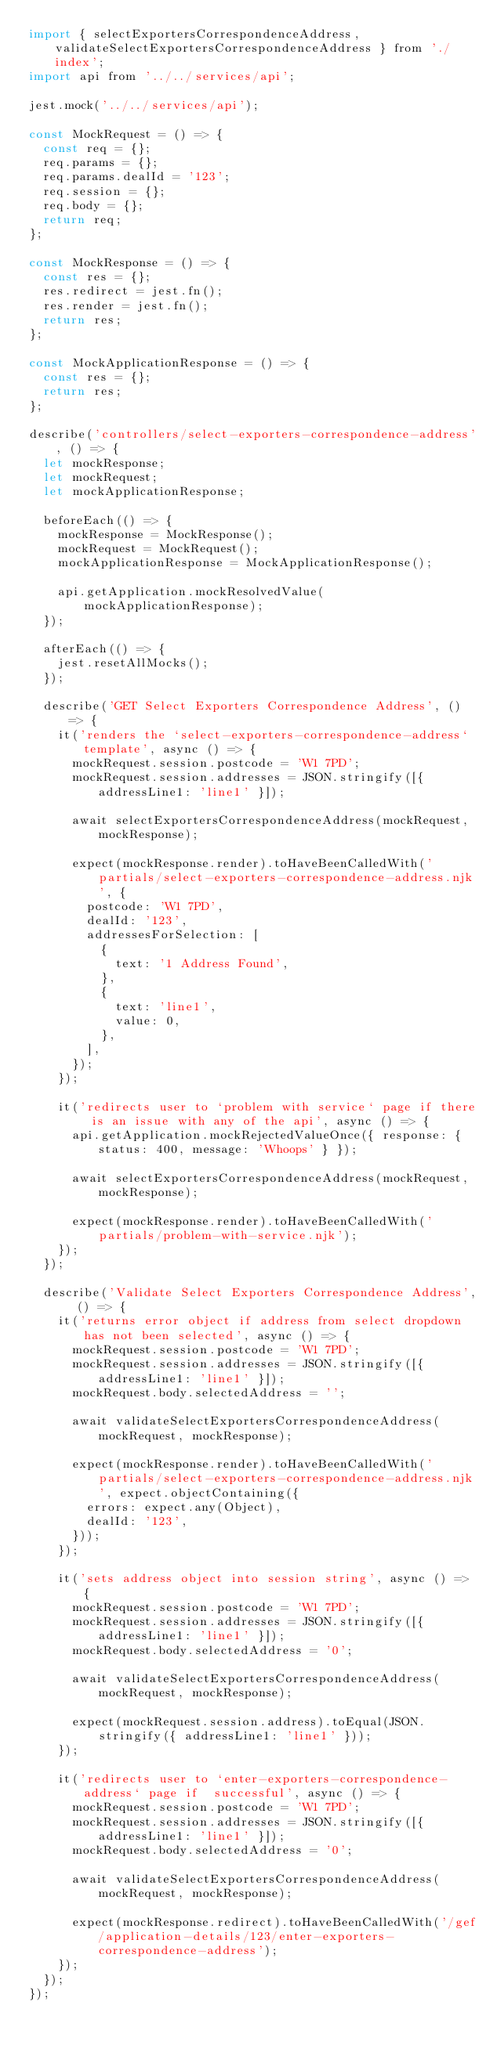Convert code to text. <code><loc_0><loc_0><loc_500><loc_500><_JavaScript_>import { selectExportersCorrespondenceAddress, validateSelectExportersCorrespondenceAddress } from './index';
import api from '../../services/api';

jest.mock('../../services/api');

const MockRequest = () => {
  const req = {};
  req.params = {};
  req.params.dealId = '123';
  req.session = {};
  req.body = {};
  return req;
};

const MockResponse = () => {
  const res = {};
  res.redirect = jest.fn();
  res.render = jest.fn();
  return res;
};

const MockApplicationResponse = () => {
  const res = {};
  return res;
};

describe('controllers/select-exporters-correspondence-address', () => {
  let mockResponse;
  let mockRequest;
  let mockApplicationResponse;

  beforeEach(() => {
    mockResponse = MockResponse();
    mockRequest = MockRequest();
    mockApplicationResponse = MockApplicationResponse();

    api.getApplication.mockResolvedValue(mockApplicationResponse);
  });

  afterEach(() => {
    jest.resetAllMocks();
  });

  describe('GET Select Exporters Correspondence Address', () => {
    it('renders the `select-exporters-correspondence-address` template', async () => {
      mockRequest.session.postcode = 'W1 7PD';
      mockRequest.session.addresses = JSON.stringify([{ addressLine1: 'line1' }]);

      await selectExportersCorrespondenceAddress(mockRequest, mockResponse);

      expect(mockResponse.render).toHaveBeenCalledWith('partials/select-exporters-correspondence-address.njk', {
        postcode: 'W1 7PD',
        dealId: '123',
        addressesForSelection: [
          {
            text: '1 Address Found',
          },
          {
            text: 'line1',
            value: 0,
          },
        ],
      });
    });

    it('redirects user to `problem with service` page if there is an issue with any of the api', async () => {
      api.getApplication.mockRejectedValueOnce({ response: { status: 400, message: 'Whoops' } });

      await selectExportersCorrespondenceAddress(mockRequest, mockResponse);

      expect(mockResponse.render).toHaveBeenCalledWith('partials/problem-with-service.njk');
    });
  });

  describe('Validate Select Exporters Correspondence Address', () => {
    it('returns error object if address from select dropdown has not been selected', async () => {
      mockRequest.session.postcode = 'W1 7PD';
      mockRequest.session.addresses = JSON.stringify([{ addressLine1: 'line1' }]);
      mockRequest.body.selectedAddress = '';

      await validateSelectExportersCorrespondenceAddress(mockRequest, mockResponse);

      expect(mockResponse.render).toHaveBeenCalledWith('partials/select-exporters-correspondence-address.njk', expect.objectContaining({
        errors: expect.any(Object),
        dealId: '123',
      }));
    });

    it('sets address object into session string', async () => {
      mockRequest.session.postcode = 'W1 7PD';
      mockRequest.session.addresses = JSON.stringify([{ addressLine1: 'line1' }]);
      mockRequest.body.selectedAddress = '0';

      await validateSelectExportersCorrespondenceAddress(mockRequest, mockResponse);

      expect(mockRequest.session.address).toEqual(JSON.stringify({ addressLine1: 'line1' }));
    });

    it('redirects user to `enter-exporters-correspondence-address` page if  successful', async () => {
      mockRequest.session.postcode = 'W1 7PD';
      mockRequest.session.addresses = JSON.stringify([{ addressLine1: 'line1' }]);
      mockRequest.body.selectedAddress = '0';

      await validateSelectExportersCorrespondenceAddress(mockRequest, mockResponse);

      expect(mockResponse.redirect).toHaveBeenCalledWith('/gef/application-details/123/enter-exporters-correspondence-address');
    });
  });
});
</code> 